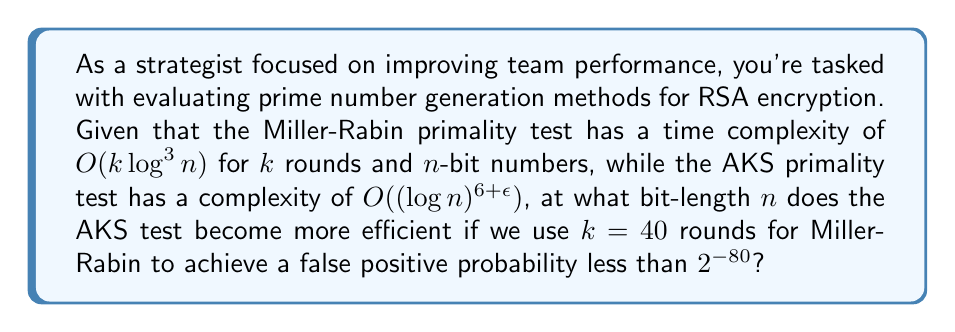What is the answer to this math problem? Let's approach this step-by-step:

1) The time complexity for Miller-Rabin is $O(k \log^3 n)$ where $k=40$ and $n$ is the bit-length.

2) The time complexity for AKS is $O((\log n)^{6+\epsilon})$. For simplicity, let's assume $\epsilon = 0$.

3) We want to find $n$ where:

   $40 \log^3 n = (\log n)^6$

4) Taking logarithms of both sides:

   $\log(40) + 3\log(\log n) = 6\log(\log n)$

5) Simplifying:

   $\log(40) = 3\log(\log n)$

6) Exponentiating both sides:

   $40 = (\log n)^3$

7) Taking the cube root:

   $\sqrt[3]{40} \approx 3.42 = \log n$

8) Exponentiating again:

   $n \approx 2^{3.42} \approx 10.7$

9) Since $n$ must be an integer, we round up to $n = 11$.

Therefore, AKS becomes more efficient when the bit-length $n$ is 11 or greater.
Answer: 11 bits 